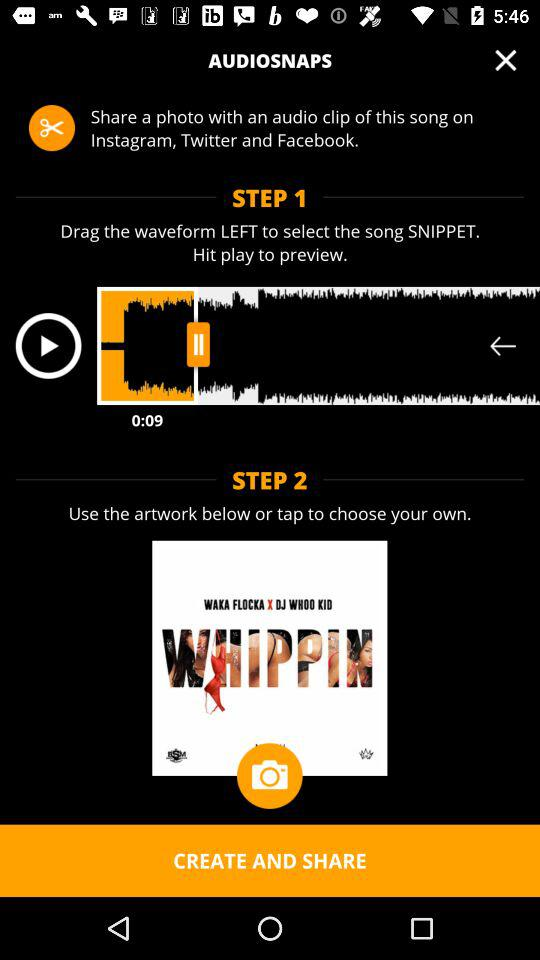How many steps are there in the process of creating a snap?
Answer the question using a single word or phrase. 2 